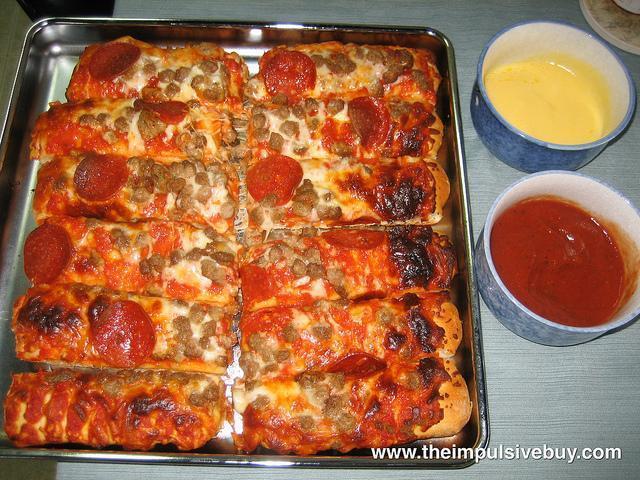How many pizzas are there?
Give a very brief answer. 1. How many bowls are visible?
Give a very brief answer. 3. 